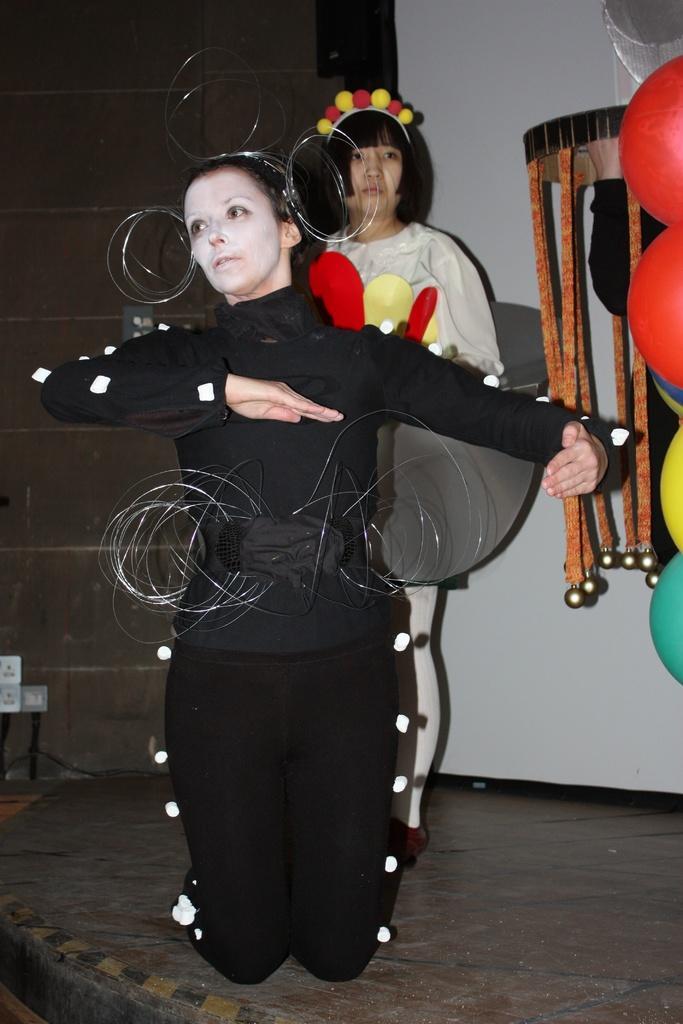Describe this image in one or two sentences. In this picture we can see people on the floor, here we can see balloons and some objects. 